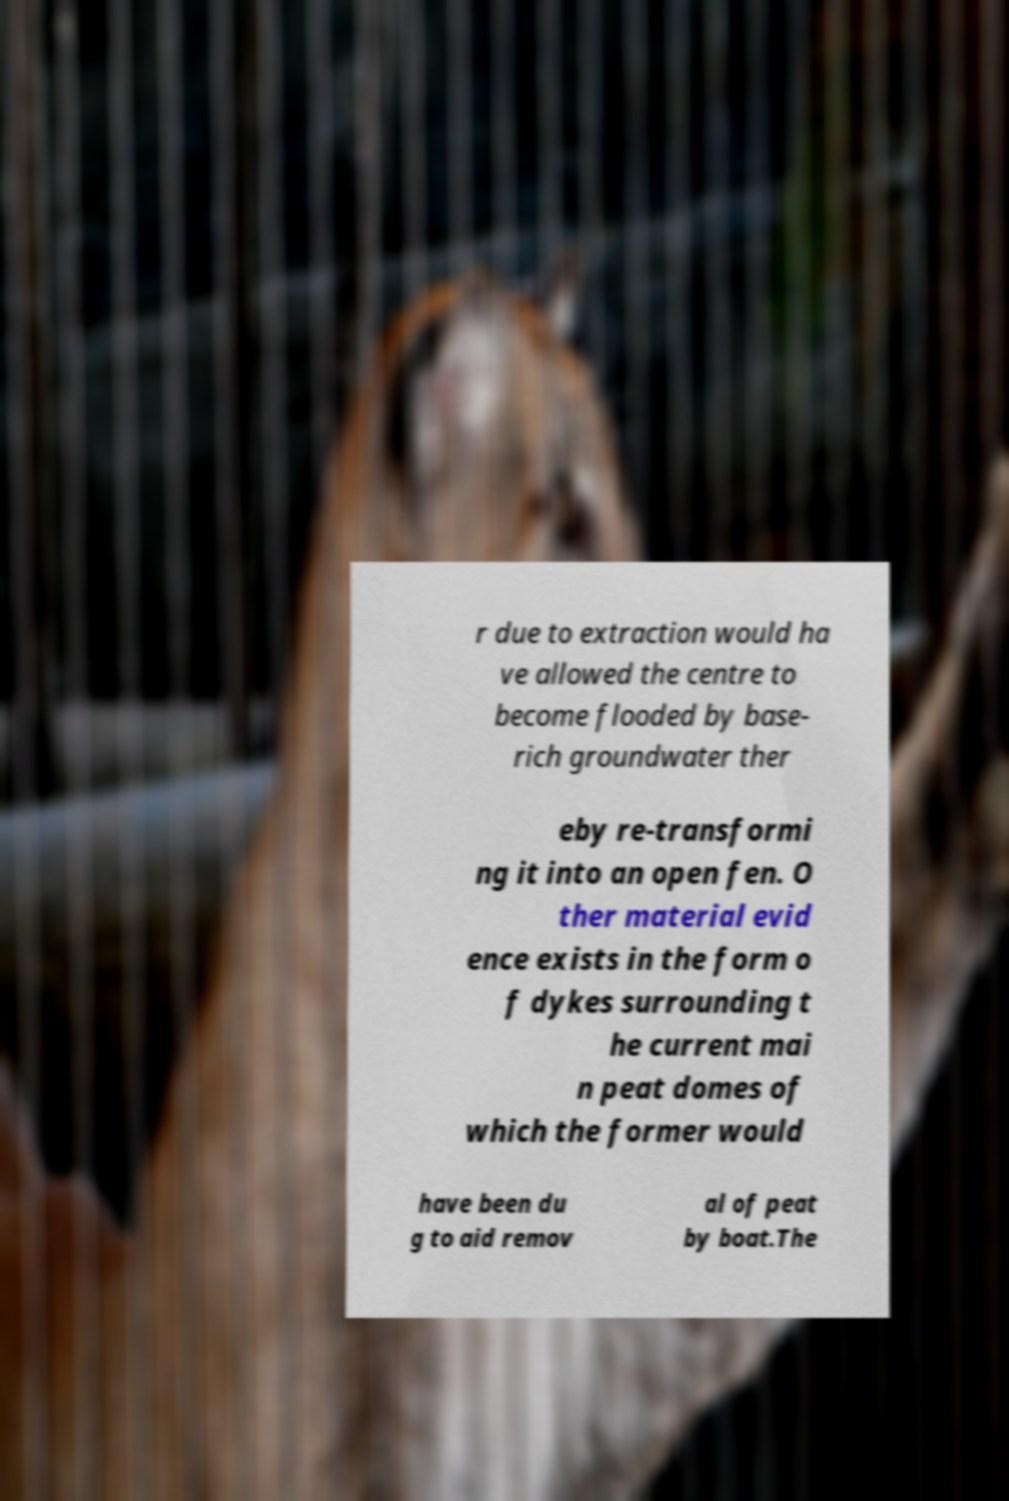For documentation purposes, I need the text within this image transcribed. Could you provide that? r due to extraction would ha ve allowed the centre to become flooded by base- rich groundwater ther eby re-transformi ng it into an open fen. O ther material evid ence exists in the form o f dykes surrounding t he current mai n peat domes of which the former would have been du g to aid remov al of peat by boat.The 